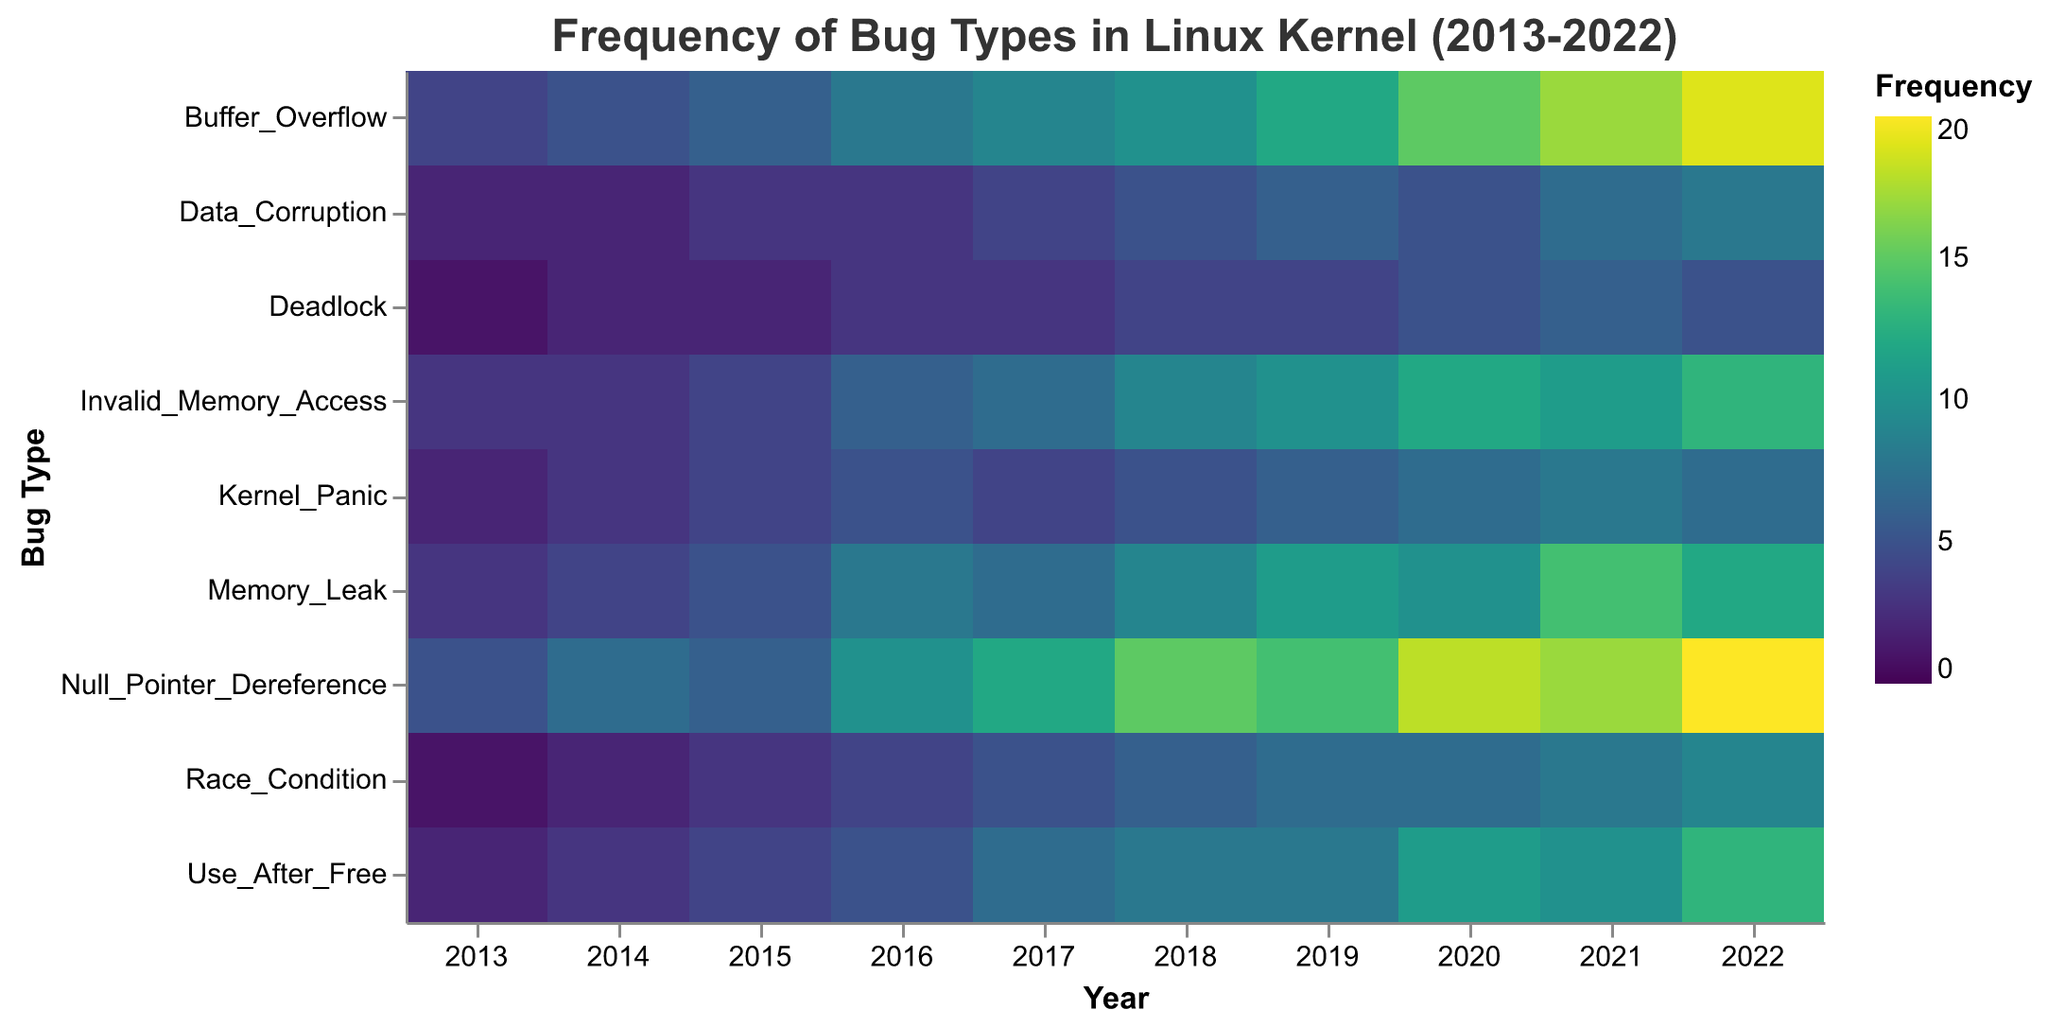What is the title of the heatmap? The title is located at the top of the heatmap and describes the figure's content.
Answer: Frequency of Bug Types in Linux Kernel (2013-2022) Which bug type had the highest frequency in 2022? By looking at the color representing 2022, the darkest color indicates the highest frequency. The darkest color in 2022 corresponds to Null Pointer Dereference.
Answer: Null Pointer Dereference How many times was the "Deadlock" bug type reported in 2015? Locate the column representing 2015 and the row labeled "Deadlock" to find the corresponding frequency value.
Answer: 2 What is the total number of Memory Leak incidents reported from 2013 to 2022? Sum the frequency values for Memory Leak across all years: 3+4+5+8+7+9+11+10+14+12.
Answer: 83 Which year had the highest number of Buffer Overflow incidents? By examining the color intensity for each year in the row labeled "Buffer Overflow," identify the year with the darkest color.
Answer: 2022 Compare the frequency of Race Condition in 2013 and 2022. Which year had more incidents? Compare the frequency values for Race Condition in 2013 (1) and 2022 (9).
Answer: 2022 What is the average frequency of "Kernel Panic" incidents reported per year over the decade? Calculate the average by summing the yearly values (2+3+4+5+4+5+6+7+8+7) and dividing by 10.
Answer: 5.1 Which bug type shows a significant increase in frequency from 2016 to 2020? Compare the color changes between 2016 and 2020 for each bug type and identify the one with a noticeable increase. For Use After Free, the frequency increases from 5 to 11.
Answer: Use After Free In which year did Invalid Memory Access first reach double digits? Examine the frequencies for Invalid Memory Access from 2013 to 2022 and find the first instance of a double-digit value, which occurs in 2019.
Answer: 2019 